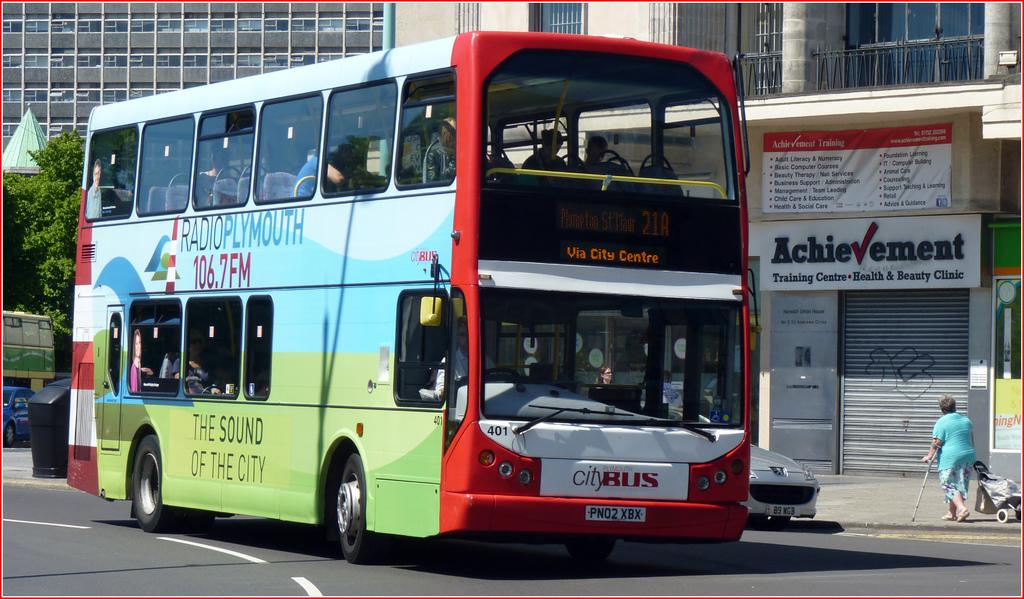<image>
Create a compact narrative representing the image presented. A large red City Bus is traveling towards Cafe Centre 